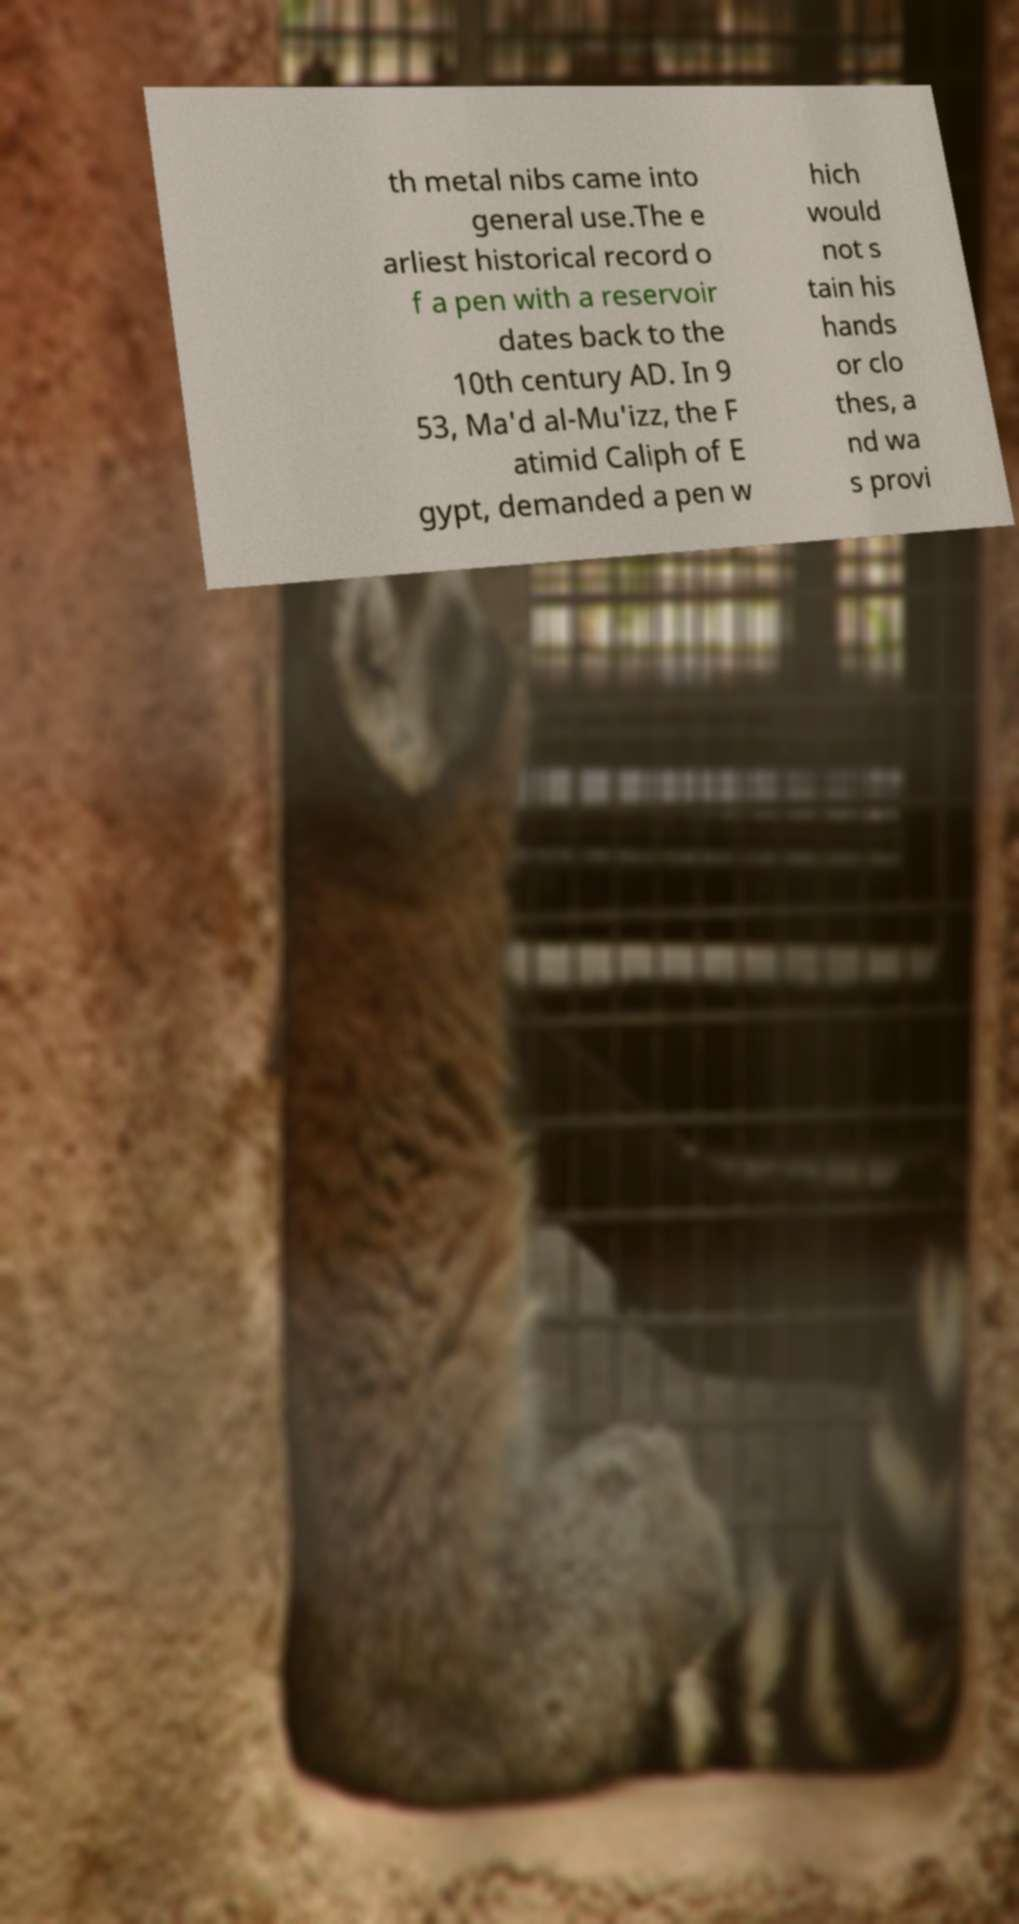I need the written content from this picture converted into text. Can you do that? th metal nibs came into general use.The e arliest historical record o f a pen with a reservoir dates back to the 10th century AD. In 9 53, Ma'd al-Mu'izz, the F atimid Caliph of E gypt, demanded a pen w hich would not s tain his hands or clo thes, a nd wa s provi 